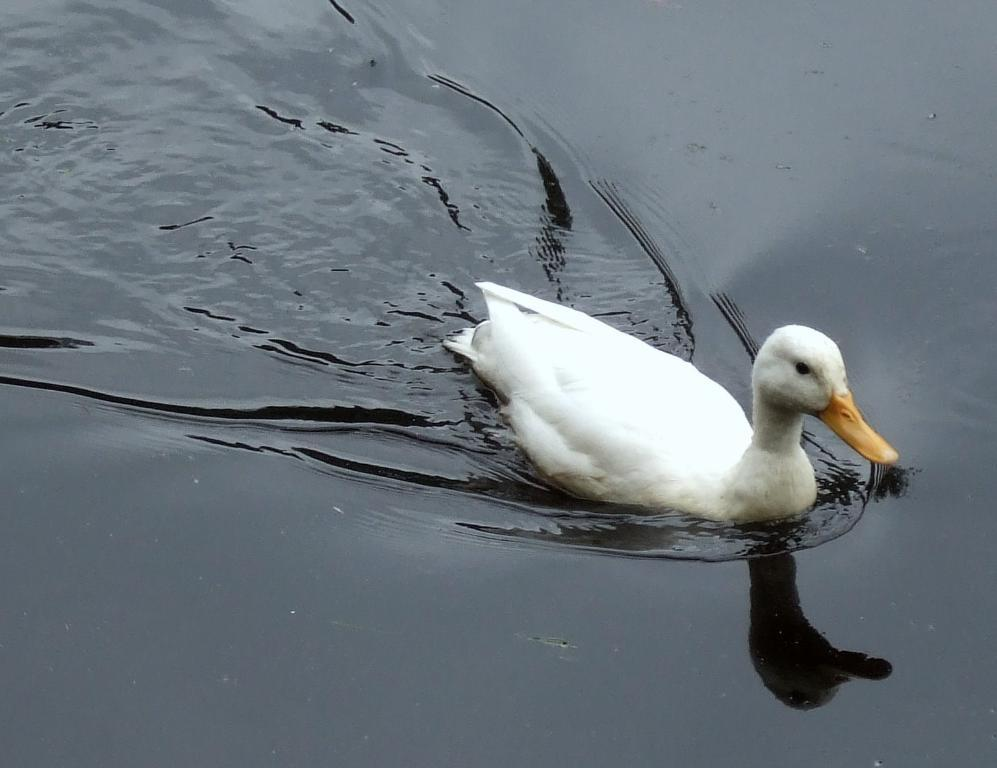What type of animal is in the image? There is a white duck in the image in the image. What is the duck doing in the image? The duck is swimming in the water. What type of farm equipment is visible in the image? There is no farm equipment present in the image; it features a white duck swimming in the water. Can you describe the rabbit's experience in the image? There is no rabbit present in the image, so it is not possible to describe its experience. 